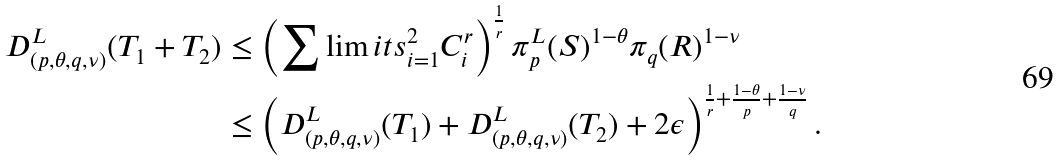Convert formula to latex. <formula><loc_0><loc_0><loc_500><loc_500>D _ { \left ( p , \theta , q , \nu \right ) } ^ { L } ( T _ { 1 } + T _ { 2 } ) & \leq \left ( \sum \lim i t s _ { i = 1 } ^ { 2 } C _ { i } ^ { r } \right ) ^ { \frac { 1 } { r } } \pi _ { p } ^ { L } ( S ) ^ { 1 - \theta } \pi _ { q } ( R ) ^ { 1 - \nu } \\ & \leq \left ( D _ { \left ( p , \theta , q , \nu \right ) } ^ { L } ( T _ { 1 } ) + D _ { \left ( p , \theta , q , \nu \right ) } ^ { L } ( T _ { 2 } ) + 2 \epsilon \right ) ^ { \frac { 1 } { r } + \frac { 1 - \theta } { p } + \frac { 1 - \nu } { q } } .</formula> 